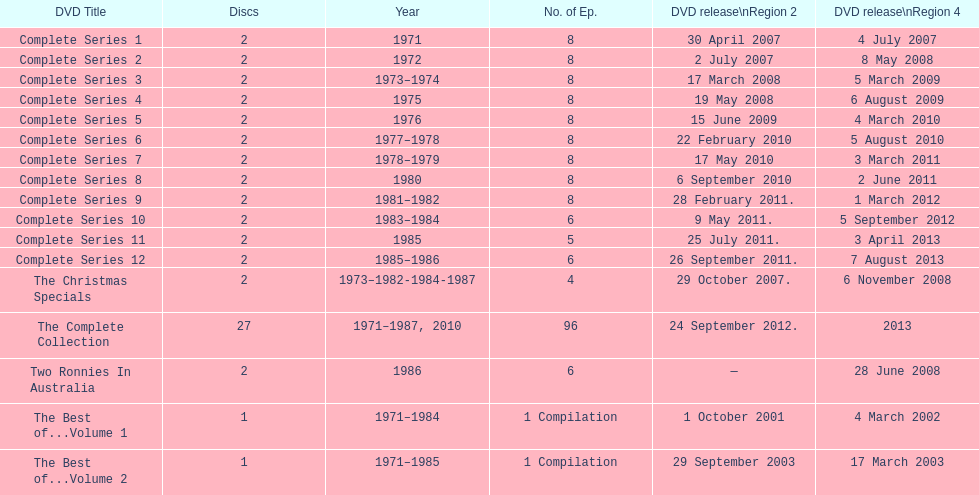What comes immediately after complete series 11? Complete Series 12. 